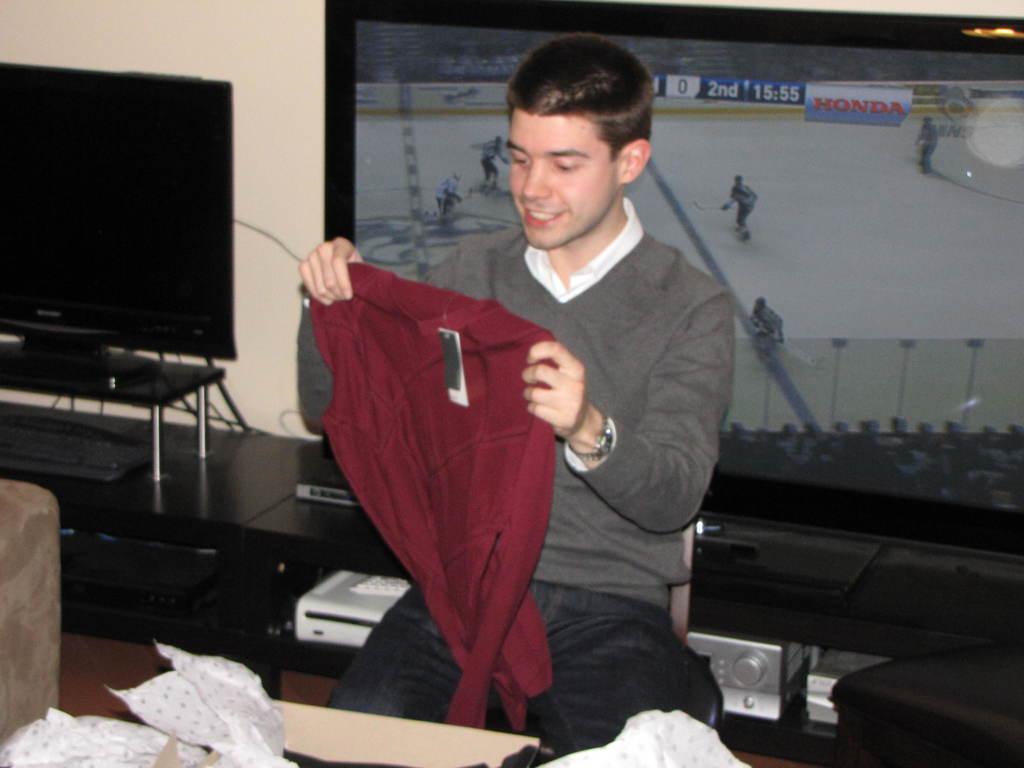What car manufacturer sponsors the hockey game on tv?
Your answer should be compact. Honda. 